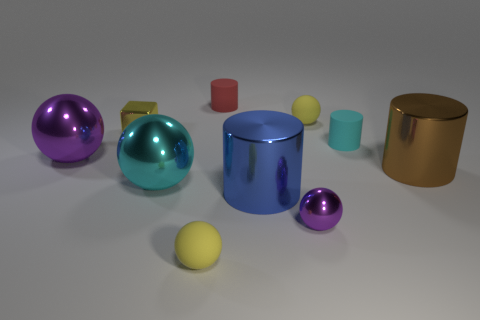There is a thing that is in front of the tiny cyan thing and on the left side of the cyan metallic thing; what size is it?
Provide a short and direct response. Large. The other small thing that is the same shape as the cyan rubber thing is what color?
Offer a terse response. Red. Is the number of small red cylinders that are right of the blue cylinder greater than the number of blue metallic cylinders to the left of the cyan metal object?
Make the answer very short. No. What number of other things are there of the same shape as the tiny purple shiny object?
Give a very brief answer. 4. Is there a blue metallic cylinder behind the big brown shiny object that is behind the small purple shiny object?
Ensure brevity in your answer.  No. How many purple balls are there?
Your answer should be compact. 2. Is the color of the tiny block the same as the tiny cylinder that is right of the red thing?
Your answer should be very brief. No. Is the number of big blue shiny cylinders greater than the number of cyan objects?
Provide a short and direct response. No. Is there any other thing of the same color as the small cube?
Your answer should be very brief. Yes. How many other things are the same size as the red cylinder?
Your response must be concise. 5. 